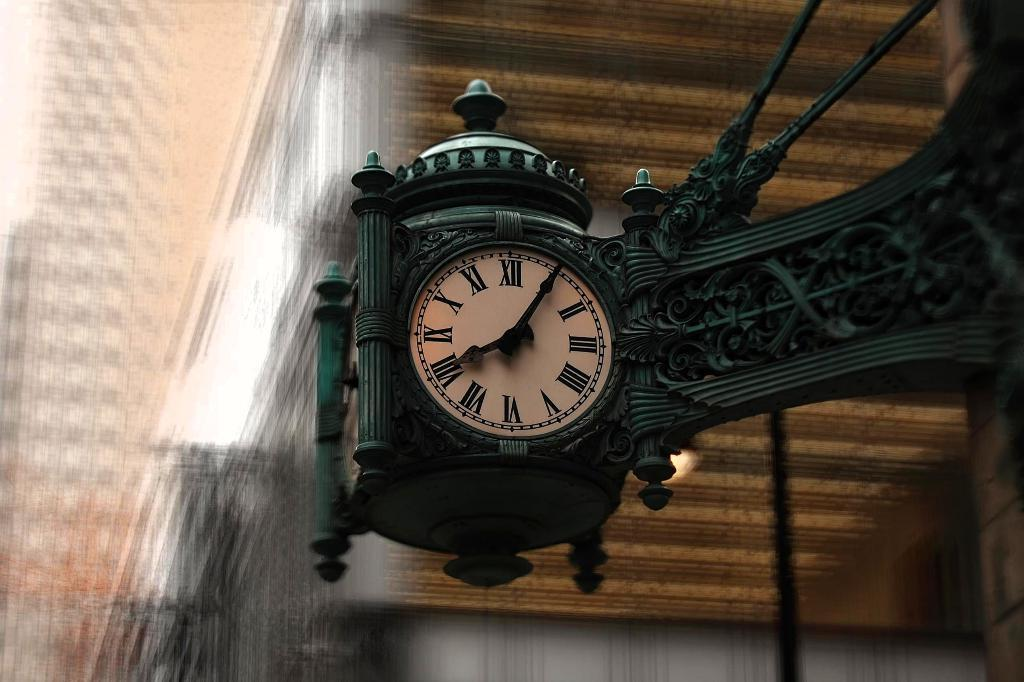<image>
Relay a brief, clear account of the picture shown. A clock face reads five minutes after eight. 